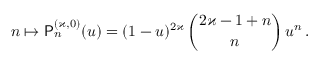<formula> <loc_0><loc_0><loc_500><loc_500>n \mapsto P _ { n } ^ { ( \varkappa , 0 ) } ( u ) = ( 1 - u ) ^ { 2 \varkappa } \, \binom { 2 \varkappa - 1 + n } { n } \, u ^ { n } \, .</formula> 